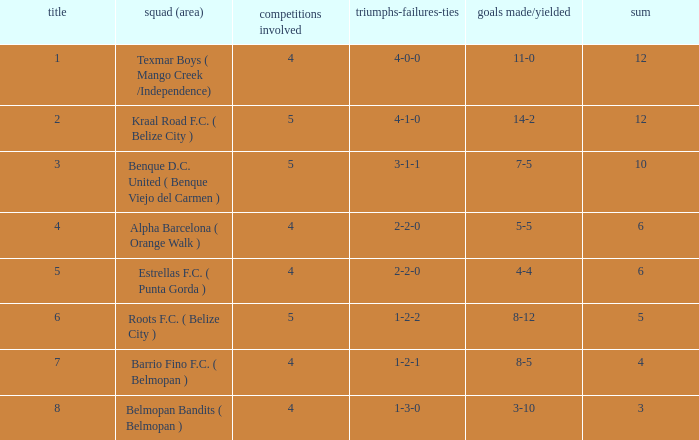What is the minimum points with goals for/against being 8-5 4.0. Could you help me parse every detail presented in this table? {'header': ['title', 'squad (area)', 'competitions involved', 'triumphs-failures-ties', 'goals made/yielded', 'sum'], 'rows': [['1', 'Texmar Boys ( Mango Creek /Independence)', '4', '4-0-0', '11-0', '12'], ['2', 'Kraal Road F.C. ( Belize City )', '5', '4-1-0', '14-2', '12'], ['3', 'Benque D.C. United ( Benque Viejo del Carmen )', '5', '3-1-1', '7-5', '10'], ['4', 'Alpha Barcelona ( Orange Walk )', '4', '2-2-0', '5-5', '6'], ['5', 'Estrellas F.C. ( Punta Gorda )', '4', '2-2-0', '4-4', '6'], ['6', 'Roots F.C. ( Belize City )', '5', '1-2-2', '8-12', '5'], ['7', 'Barrio Fino F.C. ( Belmopan )', '4', '1-2-1', '8-5', '4'], ['8', 'Belmopan Bandits ( Belmopan )', '4', '1-3-0', '3-10', '3']]} 